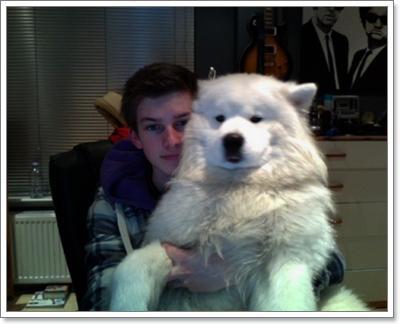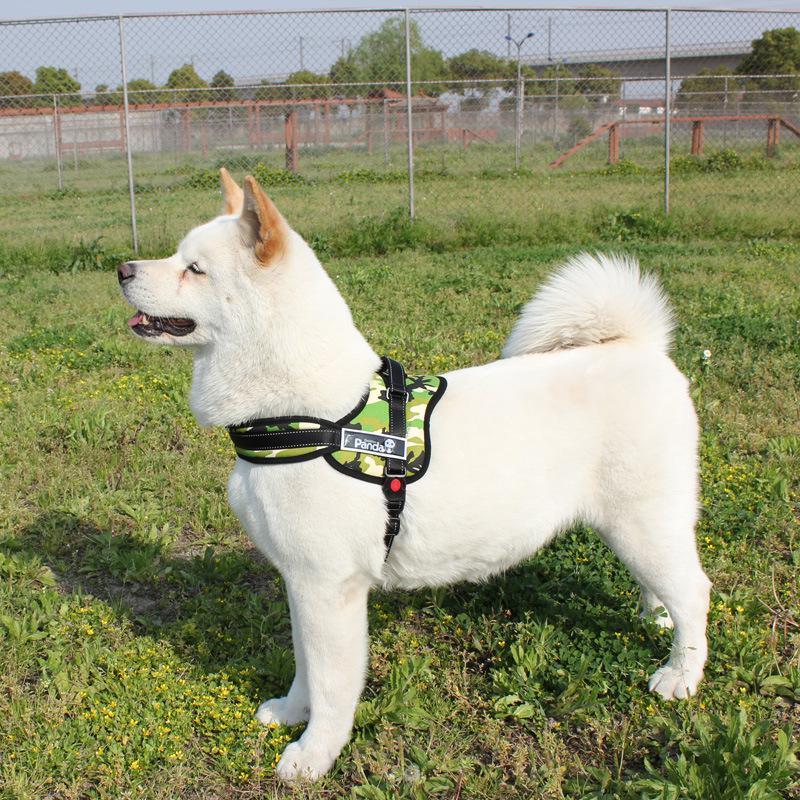The first image is the image on the left, the second image is the image on the right. Analyze the images presented: Is the assertion "One image shows a dog in a harness standing with head and body in profile, without a leash visible, and the other image shows a dog without a leash or harness." valid? Answer yes or no. Yes. The first image is the image on the left, the second image is the image on the right. For the images displayed, is the sentence "Each of two dogs at an outdoor grassy location has its mouth open with tongue showing and is wearing a leash." factually correct? Answer yes or no. No. 